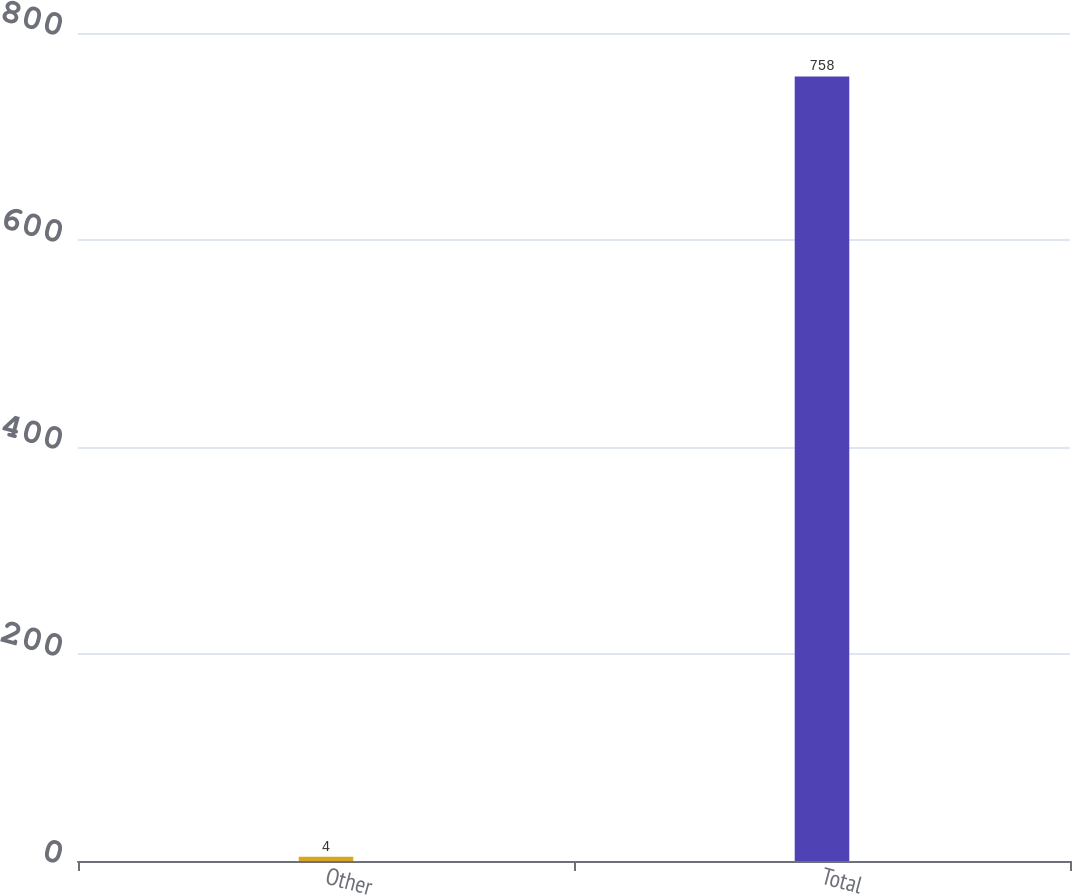<chart> <loc_0><loc_0><loc_500><loc_500><bar_chart><fcel>Other<fcel>Total<nl><fcel>4<fcel>758<nl></chart> 